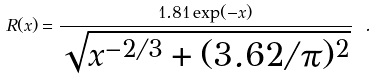Convert formula to latex. <formula><loc_0><loc_0><loc_500><loc_500>R ( x ) = \frac { 1 . 8 1 \exp ( - x ) } { \sqrt { x ^ { - 2 / 3 } + ( 3 . 6 2 / \pi ) ^ { 2 } } } \ .</formula> 